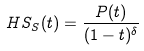<formula> <loc_0><loc_0><loc_500><loc_500>H S _ { S } ( t ) = \frac { P ( t ) } { ( 1 - t ) ^ { \delta } }</formula> 